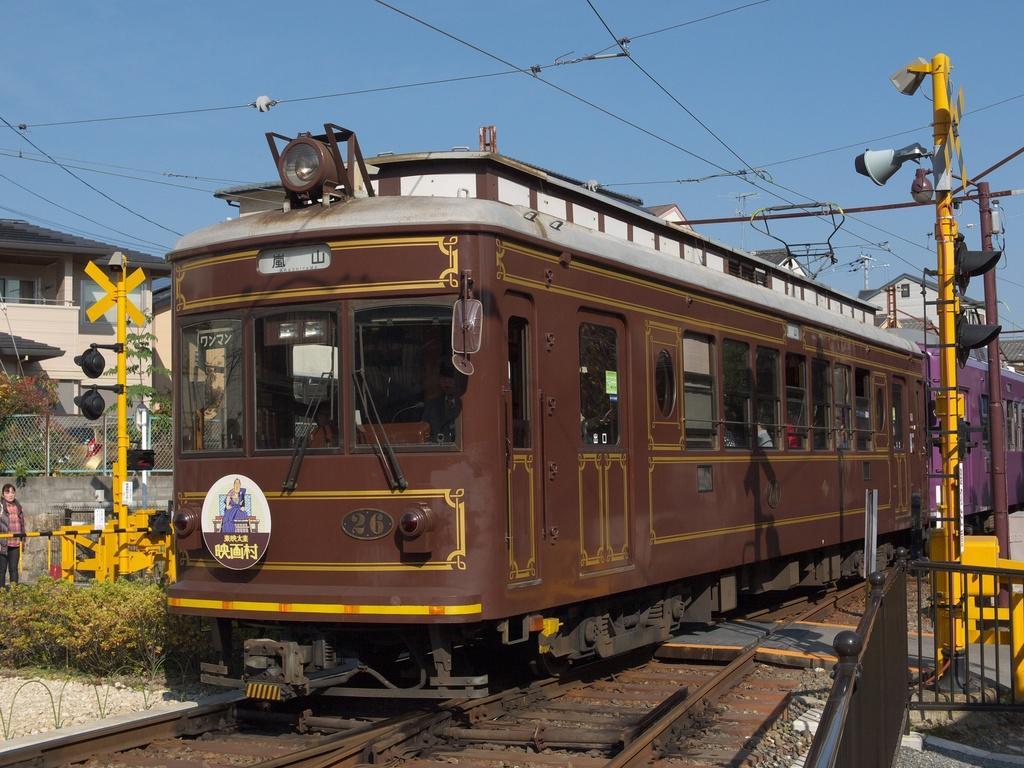Could you give a brief overview of what you see in this image? In the center of the image, we can see a train on the track and in the background, there are poles, traffic lights, wires, buildings, plants, boards, trees and a mesh and there is a lady and some railings. At the top, there is sky. 